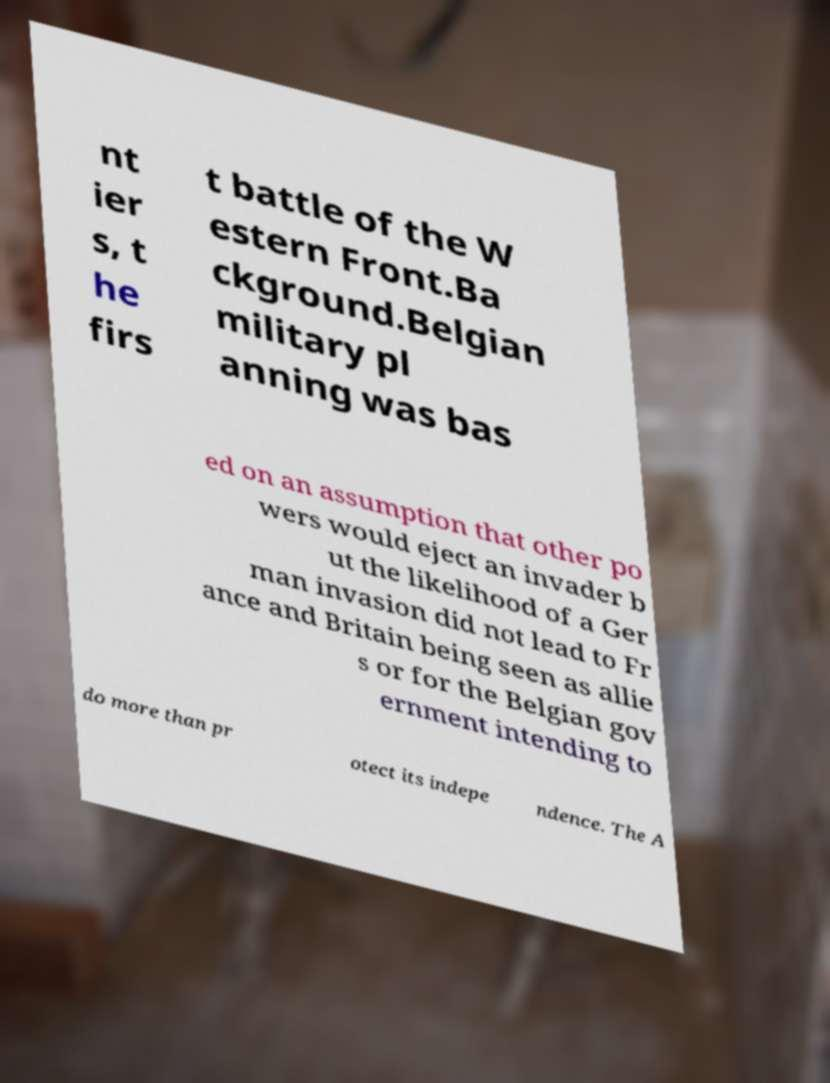I need the written content from this picture converted into text. Can you do that? nt ier s, t he firs t battle of the W estern Front.Ba ckground.Belgian military pl anning was bas ed on an assumption that other po wers would eject an invader b ut the likelihood of a Ger man invasion did not lead to Fr ance and Britain being seen as allie s or for the Belgian gov ernment intending to do more than pr otect its indepe ndence. The A 